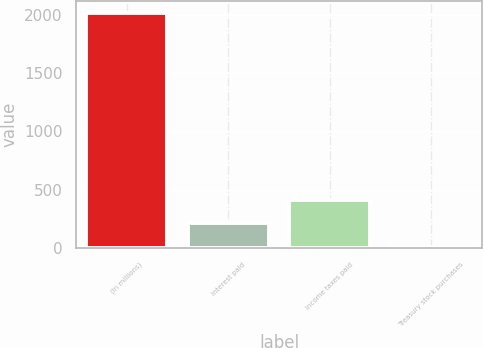<chart> <loc_0><loc_0><loc_500><loc_500><bar_chart><fcel>(In millions)<fcel>Interest paid<fcel>Income taxes paid<fcel>Treasury stock purchases<nl><fcel>2016<fcel>210.6<fcel>411.2<fcel>10<nl></chart> 